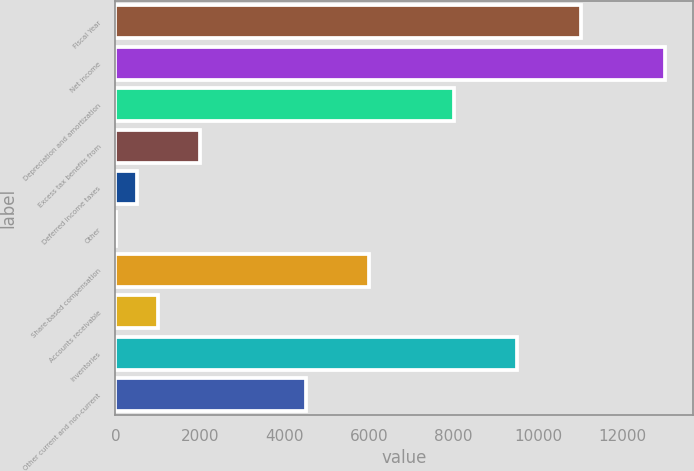Convert chart to OTSL. <chart><loc_0><loc_0><loc_500><loc_500><bar_chart><fcel>Fiscal Year<fcel>Net income<fcel>Depreciation and amortization<fcel>Excess tax benefits from<fcel>Deferred income taxes<fcel>Other<fcel>Share-based compensation<fcel>Accounts receivable<fcel>Inventories<fcel>Other current and non-current<nl><fcel>11011.2<fcel>13011.6<fcel>8010.6<fcel>2009.4<fcel>509.1<fcel>9<fcel>6010.2<fcel>1009.2<fcel>9510.9<fcel>4509.9<nl></chart> 